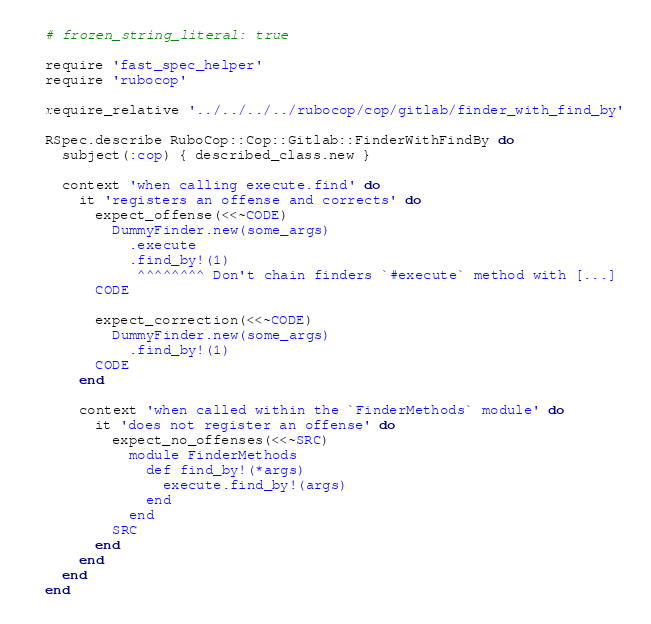<code> <loc_0><loc_0><loc_500><loc_500><_Ruby_># frozen_string_literal: true

require 'fast_spec_helper'
require 'rubocop'

require_relative '../../../../rubocop/cop/gitlab/finder_with_find_by'

RSpec.describe RuboCop::Cop::Gitlab::FinderWithFindBy do
  subject(:cop) { described_class.new }

  context 'when calling execute.find' do
    it 'registers an offense and corrects' do
      expect_offense(<<~CODE)
        DummyFinder.new(some_args)
          .execute
          .find_by!(1)
           ^^^^^^^^ Don't chain finders `#execute` method with [...]
      CODE

      expect_correction(<<~CODE)
        DummyFinder.new(some_args)
          .find_by!(1)
      CODE
    end

    context 'when called within the `FinderMethods` module' do
      it 'does not register an offense' do
        expect_no_offenses(<<~SRC)
          module FinderMethods
            def find_by!(*args)
              execute.find_by!(args)
            end
          end
        SRC
      end
    end
  end
end
</code> 